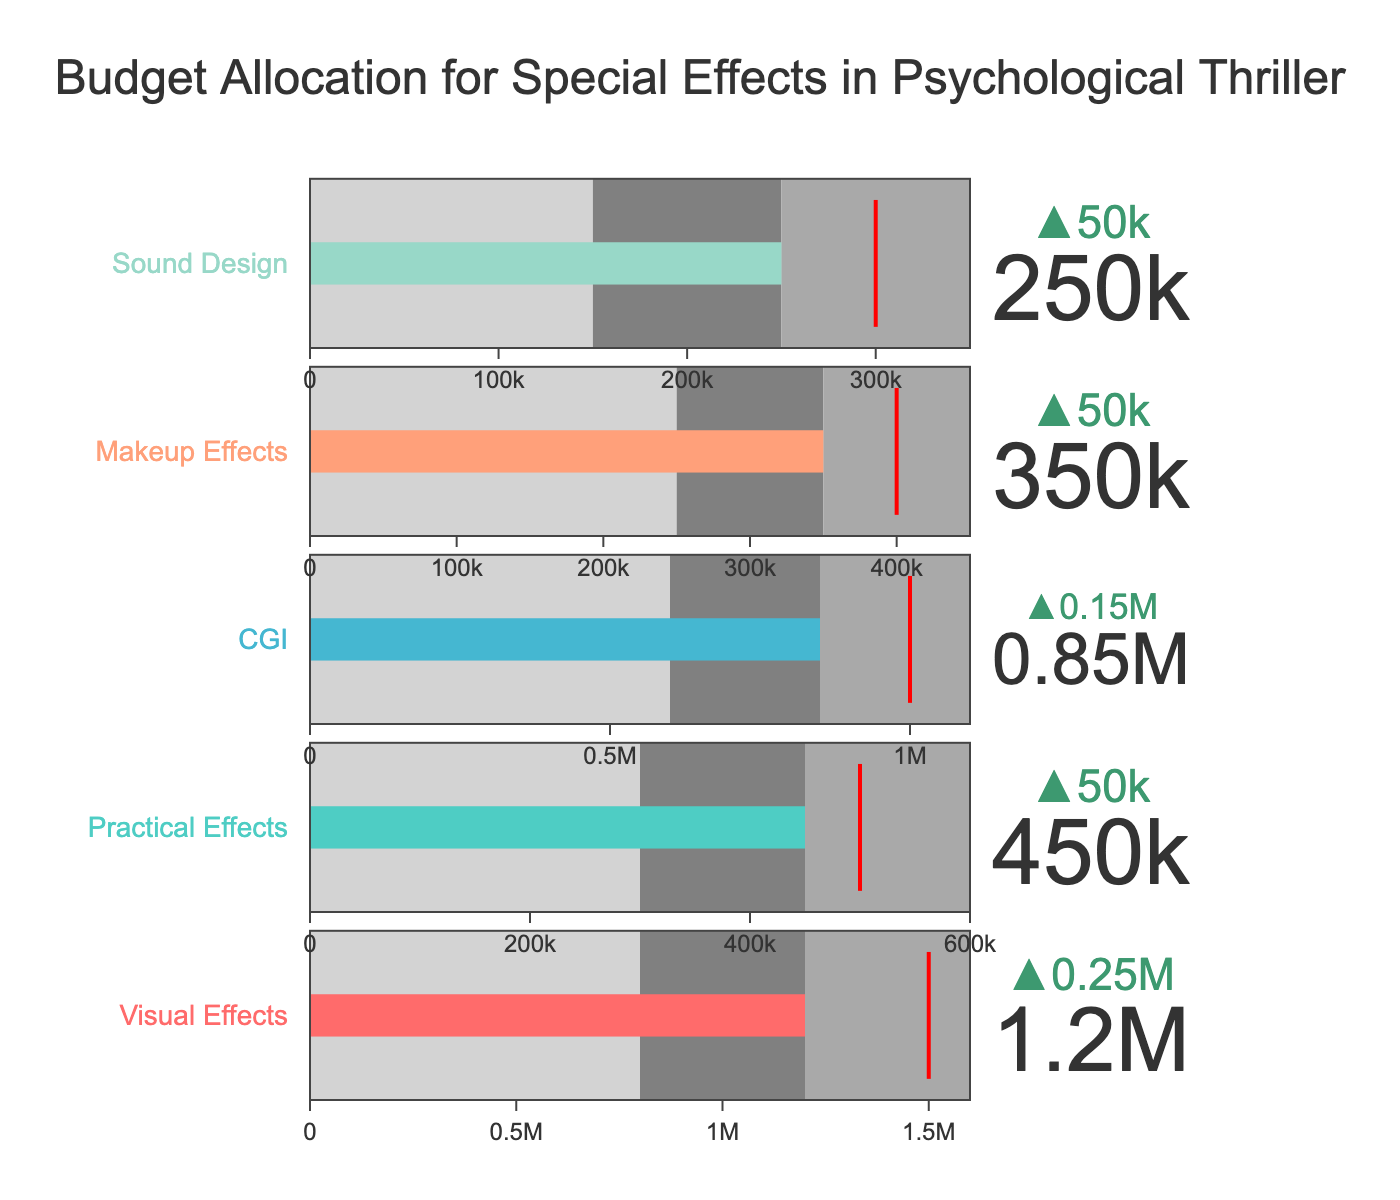What is the title of the figure? The title is prominently displayed at the top of the figure.
Answer: Budget Allocation for Special Effects in Psychological Thriller What color represents the Visual Effects bar? The Visual Effects bar color is distinct and indicated next to its title at the top left of its respective bullet chart.
Answer: Red What is the target budget for CGI effects? The target budget is indicated by a red threshold line on the bar representing CGI effects.
Answer: 1,000,000 Which category has the highest actual budget? The highest actual budget can be detected by comparing the lengths of all the bars labeled under "Actual".
Answer: Visual Effects Is the actual budget for Sound Design above or below the comparative budget? Delta indicators above each bar show if the actual budget is above or below the comparative budget. For Sound Design, it shows a decrease (negative delta).
Answer: Below What is the total budget for Practical Effects and Makeup Effects? Sum the actual budgets of Practical Effects and Makeup Effects: 450,000 + 350,000 = 800,000.
Answer: 800,000 Which category’s actual budget is closest to the medium range? Examine where the actual budget bars fall relative to the medium range within each category.
Answer: Makeup Effects By how much does the actual budget for Visual Effects exceed the comparative budget? The delta indicator above the Visual Effects bar shows the difference between the actual and comparative budgets: 1,200,000 - 950,000 = 250,000.
Answer: 250,000 Which categories have actual budgets within their high range? Identify bars that fall between the medium and high bands for the respective categories.
Answer: Visual Effects, CGI Are there any categories where the actual budget exactly meets the target? Look for bars that intersect precisely with the threshold line indicating the target.
Answer: No 